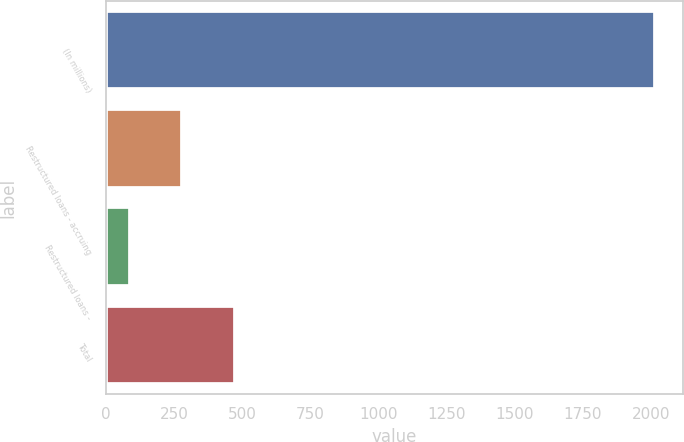<chart> <loc_0><loc_0><loc_500><loc_500><bar_chart><fcel>(In millions)<fcel>Restructured loans - accruing<fcel>Restructured loans -<fcel>Total<nl><fcel>2017<fcel>280<fcel>87<fcel>473<nl></chart> 